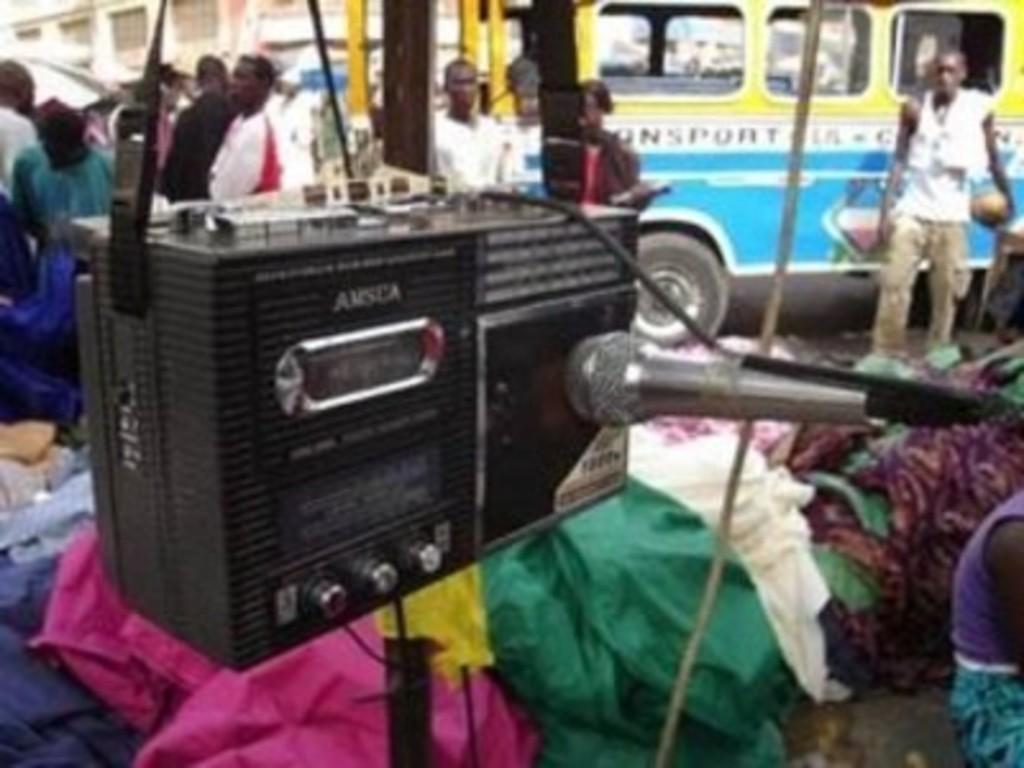Please provide a concise description of this image. In this image in the center there is one radio and mike, and in the background there are some clothes and some persons, bus and buildings and also in the foreground there is one rope. 